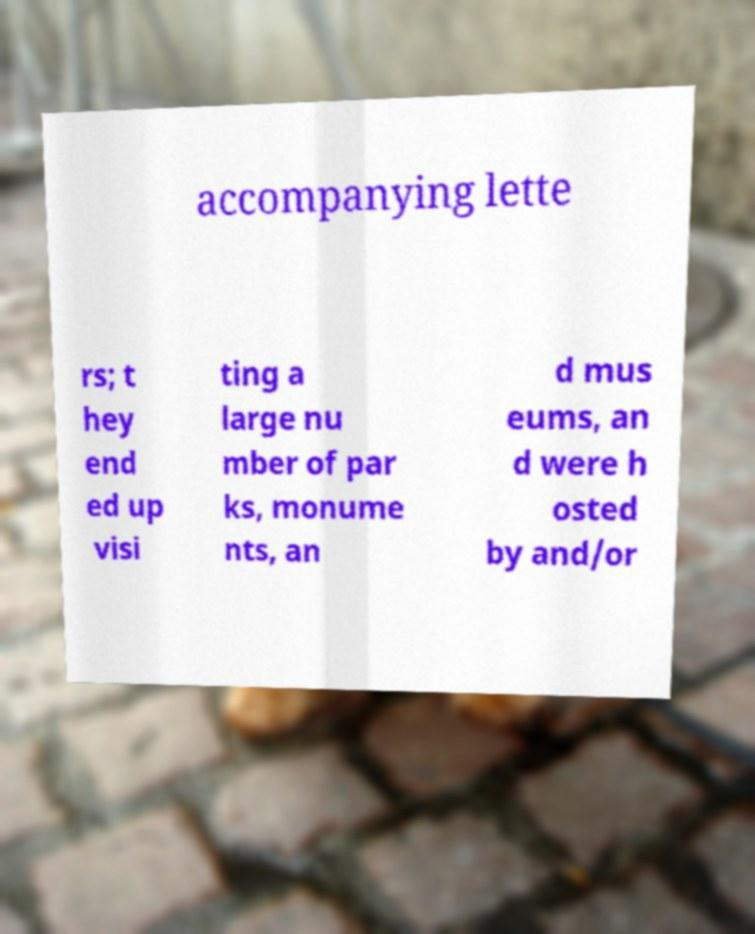There's text embedded in this image that I need extracted. Can you transcribe it verbatim? accompanying lette rs; t hey end ed up visi ting a large nu mber of par ks, monume nts, an d mus eums, an d were h osted by and/or 